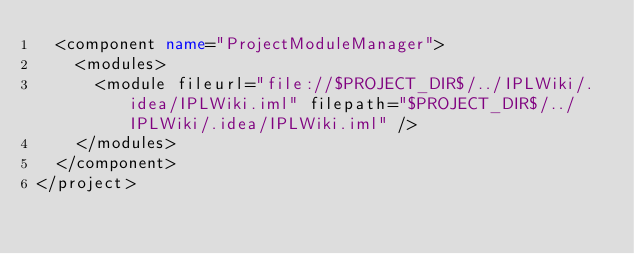Convert code to text. <code><loc_0><loc_0><loc_500><loc_500><_XML_>  <component name="ProjectModuleManager">
    <modules>
      <module fileurl="file://$PROJECT_DIR$/../IPLWiki/.idea/IPLWiki.iml" filepath="$PROJECT_DIR$/../IPLWiki/.idea/IPLWiki.iml" />
    </modules>
  </component>
</project></code> 